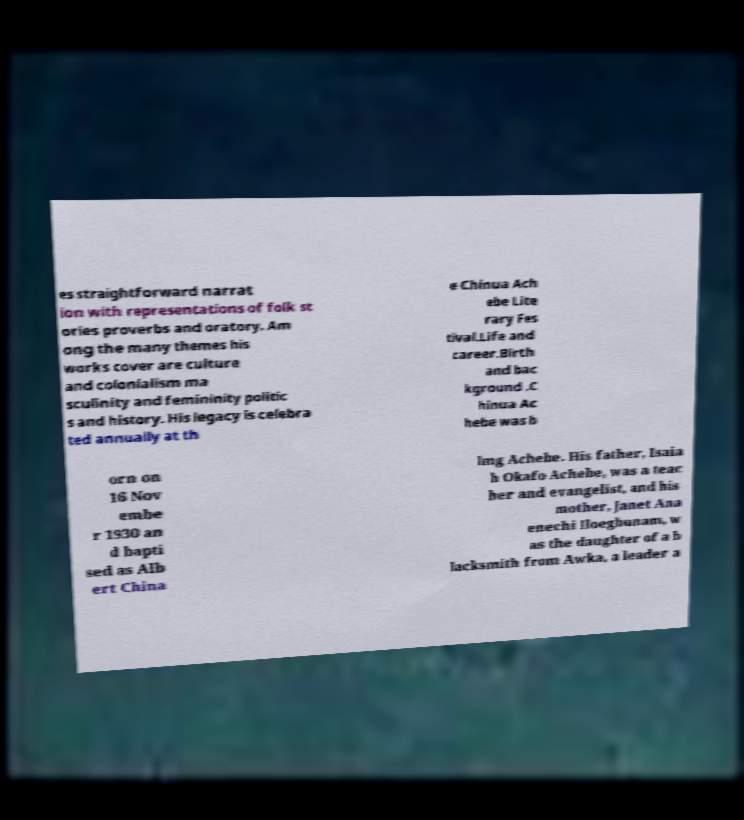Please read and relay the text visible in this image. What does it say? es straightforward narrat ion with representations of folk st ories proverbs and oratory. Am ong the many themes his works cover are culture and colonialism ma sculinity and femininity politic s and history. His legacy is celebra ted annually at th e Chinua Ach ebe Lite rary Fes tival.Life and career.Birth and bac kground .C hinua Ac hebe was b orn on 16 Nov embe r 1930 an d bapti sed as Alb ert China lmg Achebe. His father, Isaia h Okafo Achebe, was a teac her and evangelist, and his mother, Janet Ana enechi Iloegbunam, w as the daughter of a b lacksmith from Awka, a leader a 